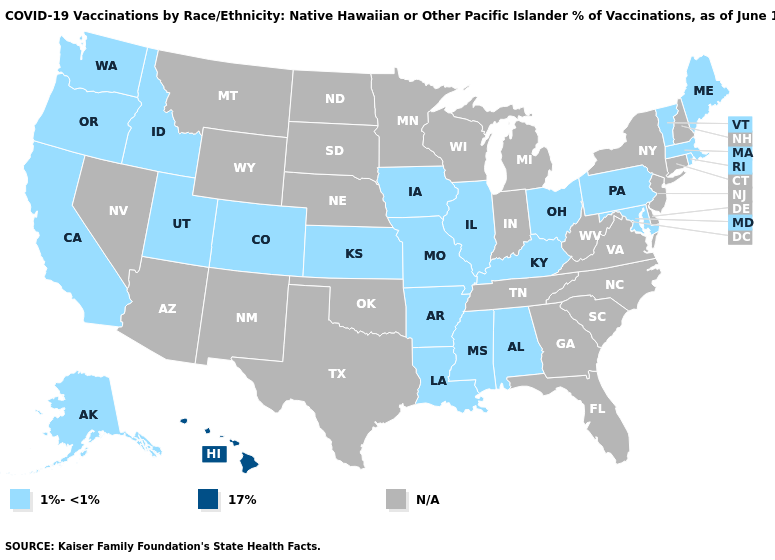Among the states that border Iowa , which have the highest value?
Quick response, please. Illinois, Missouri. Does Idaho have the lowest value in the West?
Write a very short answer. Yes. Name the states that have a value in the range 1%-<1%?
Keep it brief. Alabama, Alaska, Arkansas, California, Colorado, Idaho, Illinois, Iowa, Kansas, Kentucky, Louisiana, Maine, Maryland, Massachusetts, Mississippi, Missouri, Ohio, Oregon, Pennsylvania, Rhode Island, Utah, Vermont, Washington. Which states have the lowest value in the West?
Write a very short answer. Alaska, California, Colorado, Idaho, Oregon, Utah, Washington. Among the states that border California , which have the lowest value?
Be succinct. Oregon. Does Alabama have the lowest value in the USA?
Answer briefly. Yes. What is the lowest value in states that border Ohio?
Give a very brief answer. 1%-<1%. What is the value of Maine?
Quick response, please. 1%-<1%. What is the value of Maine?
Keep it brief. 1%-<1%. Does Kansas have the highest value in the USA?
Write a very short answer. No. 